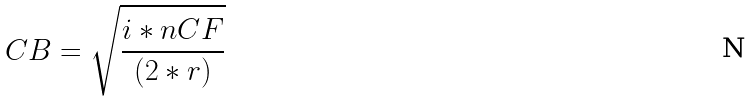Convert formula to latex. <formula><loc_0><loc_0><loc_500><loc_500>C B = \sqrt { \frac { i * n C F } { ( 2 * r ) } }</formula> 